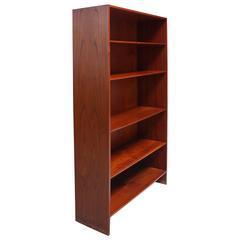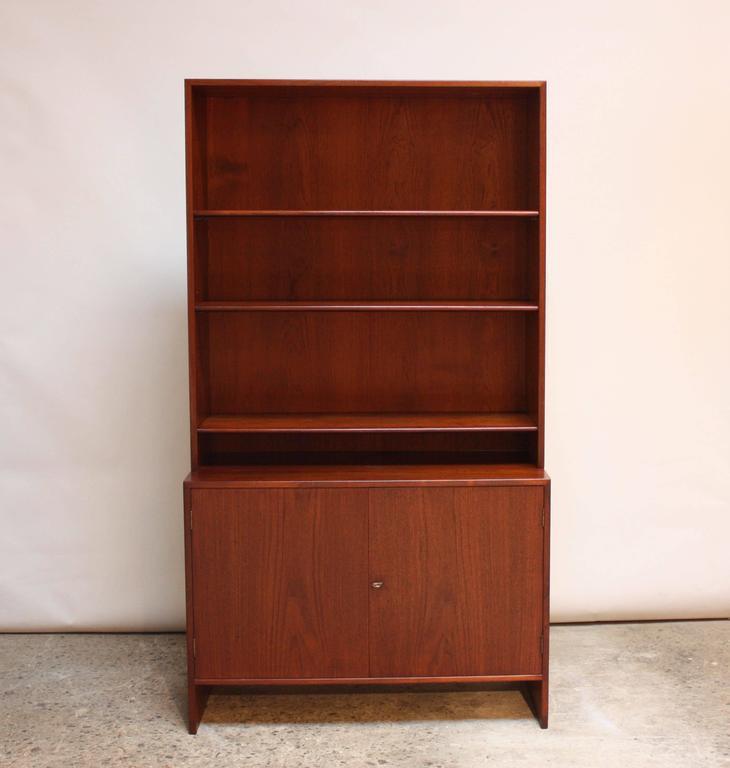The first image is the image on the left, the second image is the image on the right. Examine the images to the left and right. Is the description "One piece of furniture has exactly five shelves." accurate? Answer yes or no. Yes. The first image is the image on the left, the second image is the image on the right. Assess this claim about the two images: "One image contains a tall, brown bookshelf; and the other contains a bookshelf with cupboards at the bottom.". Correct or not? Answer yes or no. Yes. 